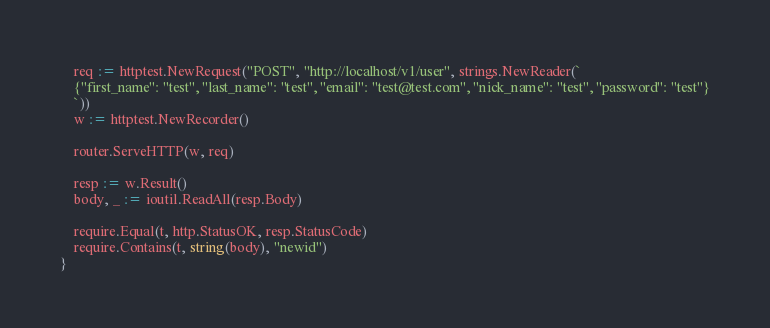<code> <loc_0><loc_0><loc_500><loc_500><_Go_>	req := httptest.NewRequest("POST", "http://localhost/v1/user", strings.NewReader(`
	{"first_name": "test", "last_name": "test", "email": "test@test.com", "nick_name": "test", "password": "test"}
	`))
	w := httptest.NewRecorder()

	router.ServeHTTP(w, req)

	resp := w.Result()
	body, _ := ioutil.ReadAll(resp.Body)

	require.Equal(t, http.StatusOK, resp.StatusCode)
	require.Contains(t, string(body), "newid")
}
</code> 